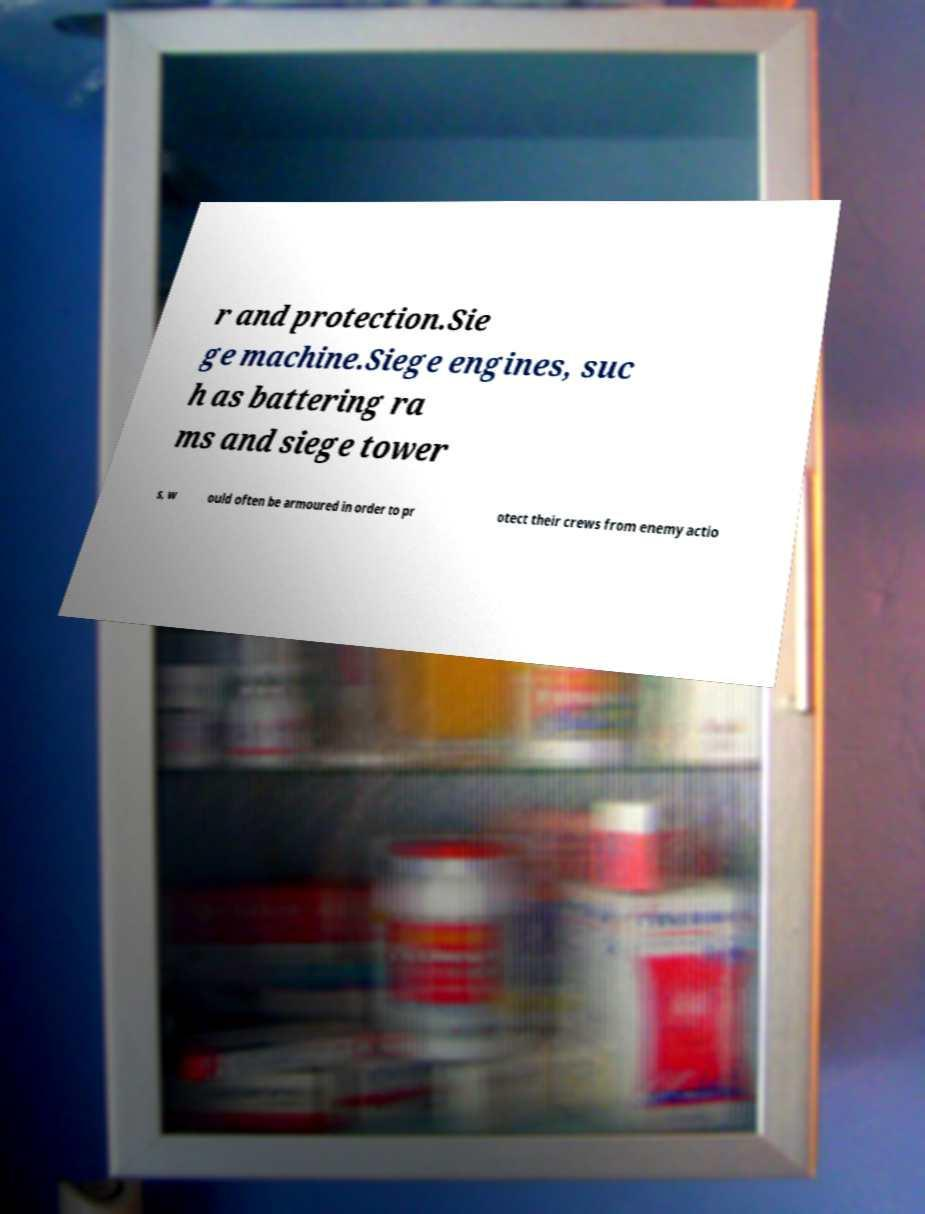Could you extract and type out the text from this image? r and protection.Sie ge machine.Siege engines, suc h as battering ra ms and siege tower s, w ould often be armoured in order to pr otect their crews from enemy actio 